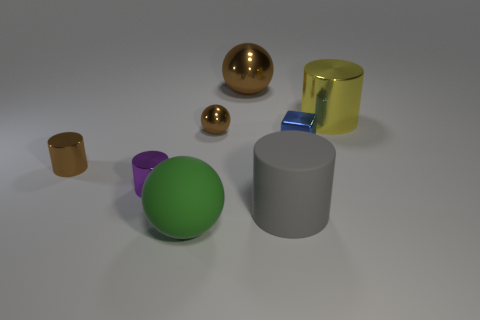Subtract 1 cylinders. How many cylinders are left? 3 Add 1 gray cylinders. How many objects exist? 9 Subtract all green cylinders. Subtract all purple balls. How many cylinders are left? 4 Subtract all blocks. How many objects are left? 7 Subtract 1 green spheres. How many objects are left? 7 Subtract all large brown blocks. Subtract all brown spheres. How many objects are left? 6 Add 4 tiny balls. How many tiny balls are left? 5 Add 4 big matte spheres. How many big matte spheres exist? 5 